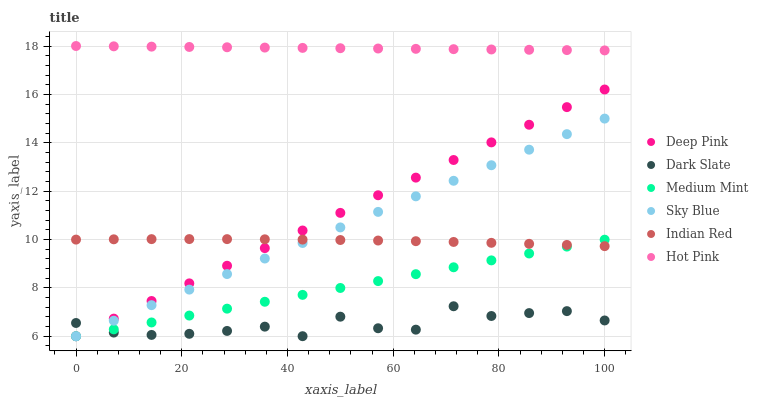Does Dark Slate have the minimum area under the curve?
Answer yes or no. Yes. Does Hot Pink have the maximum area under the curve?
Answer yes or no. Yes. Does Deep Pink have the minimum area under the curve?
Answer yes or no. No. Does Deep Pink have the maximum area under the curve?
Answer yes or no. No. Is Deep Pink the smoothest?
Answer yes or no. Yes. Is Dark Slate the roughest?
Answer yes or no. Yes. Is Hot Pink the smoothest?
Answer yes or no. No. Is Hot Pink the roughest?
Answer yes or no. No. Does Medium Mint have the lowest value?
Answer yes or no. Yes. Does Hot Pink have the lowest value?
Answer yes or no. No. Does Hot Pink have the highest value?
Answer yes or no. Yes. Does Deep Pink have the highest value?
Answer yes or no. No. Is Sky Blue less than Hot Pink?
Answer yes or no. Yes. Is Indian Red greater than Dark Slate?
Answer yes or no. Yes. Does Deep Pink intersect Medium Mint?
Answer yes or no. Yes. Is Deep Pink less than Medium Mint?
Answer yes or no. No. Is Deep Pink greater than Medium Mint?
Answer yes or no. No. Does Sky Blue intersect Hot Pink?
Answer yes or no. No. 